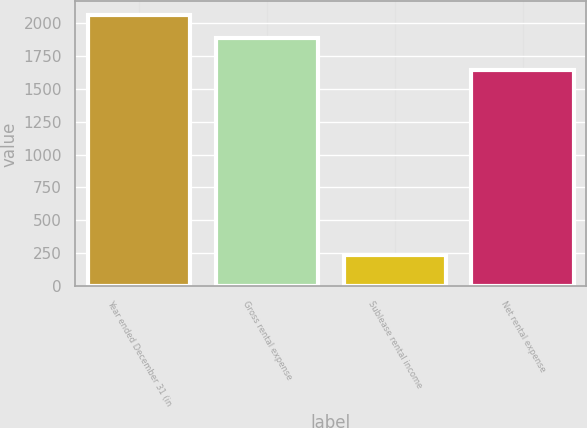Convert chart. <chart><loc_0><loc_0><loc_500><loc_500><bar_chart><fcel>Year ended December 31 (in<fcel>Gross rental expense<fcel>Sublease rental income<fcel>Net rental expense<nl><fcel>2058.9<fcel>1881<fcel>239<fcel>1642<nl></chart> 